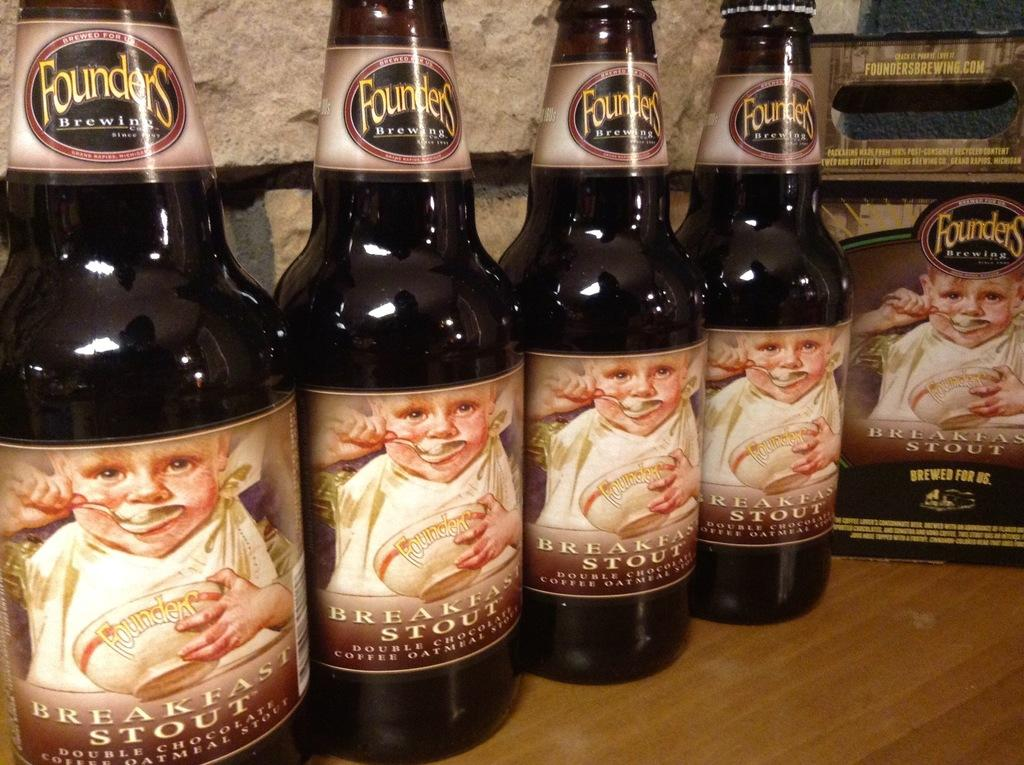<image>
Render a clear and concise summary of the photo. Several bottles of Founders beer called Breakfast Stout. 